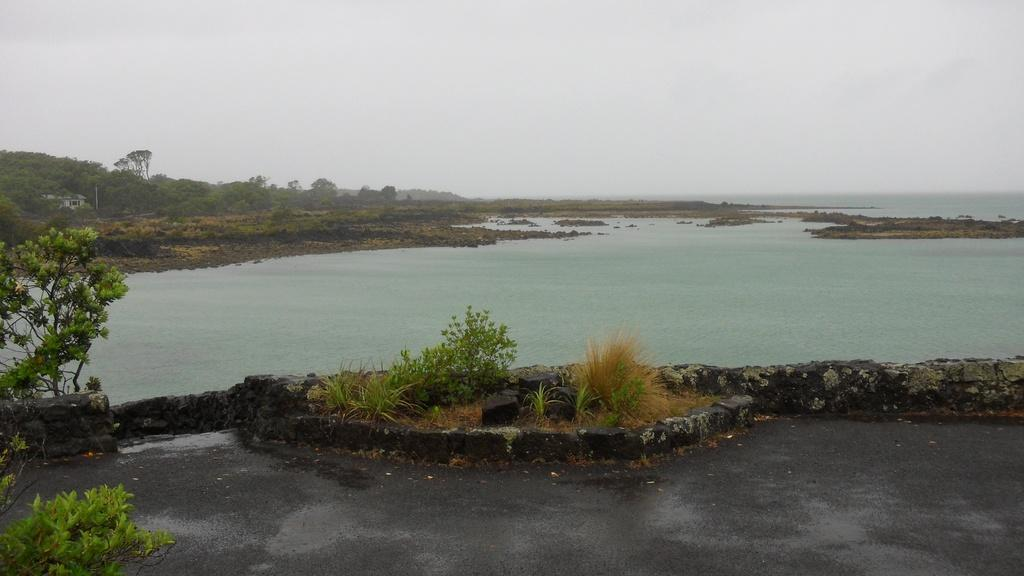What type of natural elements can be seen in the image? There are trees and plants visible in the image. What type of man-made structure is present in the image? There is a building in the image. What type of transportation infrastructure is present in the image? There is a road in the image. What type of water feature can be seen in the image? There is water visible in the image. What part of the natural environment is visible in the background of the image? The sky is visible in the background of the image. What type of pancake is being served with honey in the image? There is no pancake or honey present in the image. Can you see any steam coming from the water in the image? There is no steam visible in the image. 